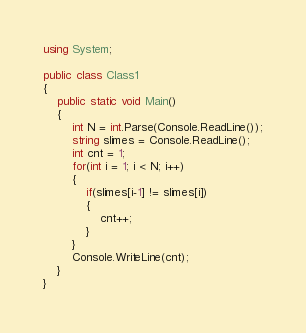Convert code to text. <code><loc_0><loc_0><loc_500><loc_500><_C#_>using System;

public class Class1
{
	public static void Main()
	{
        int N = int.Parse(Console.ReadLine());
        string slimes = Console.ReadLine();
        int cnt = 1;
        for(int i = 1; i < N; i++)
        {
            if(slimes[i-1] != slimes[i])
            {
                cnt++;
            }
        }
        Console.WriteLine(cnt);
    }
}
</code> 